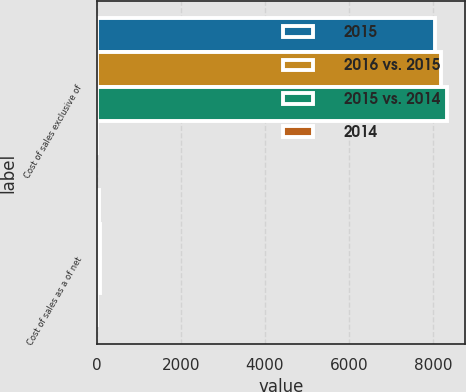Convert chart. <chart><loc_0><loc_0><loc_500><loc_500><stacked_bar_chart><ecel><fcel>Cost of sales exclusive of<fcel>Cost of sales as a of net<nl><fcel>2015<fcel>8063<fcel>54.7<nl><fcel>2016 vs. 2015<fcel>8206<fcel>55.6<nl><fcel>2015 vs. 2014<fcel>8348<fcel>56.4<nl><fcel>2014<fcel>1.7<fcel>0.9<nl></chart> 